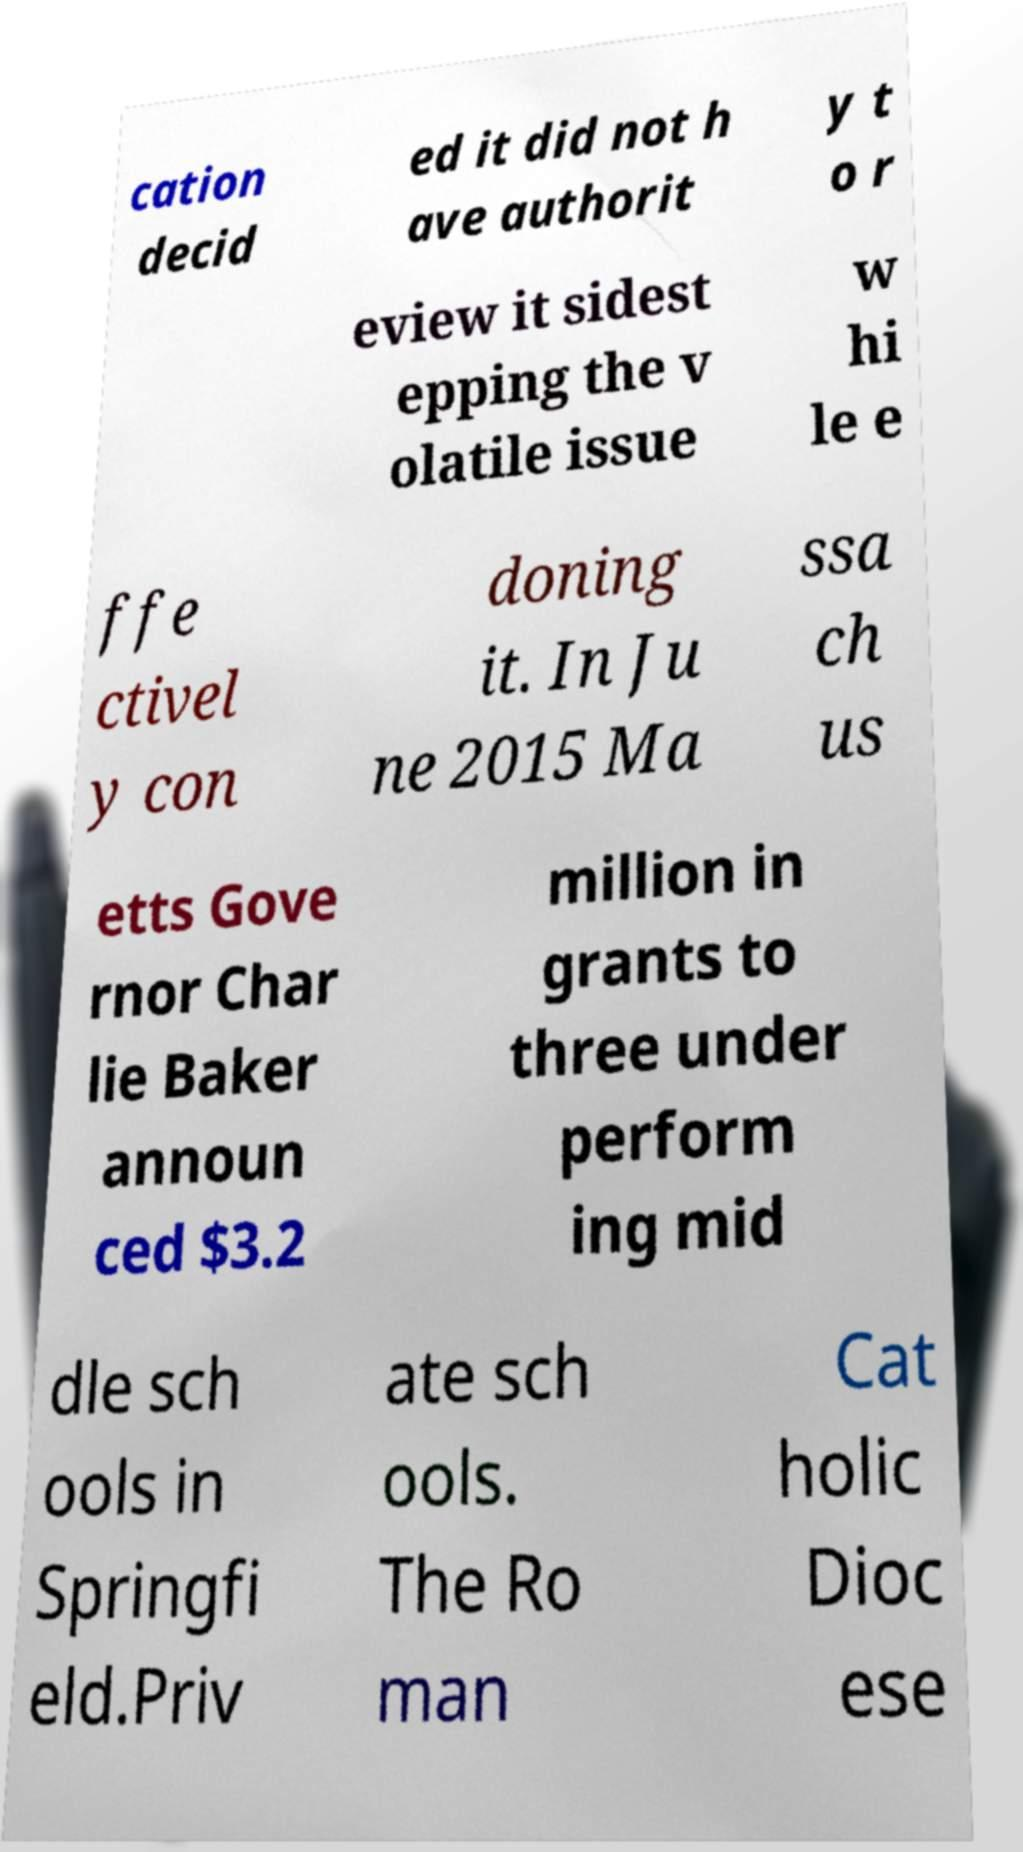For documentation purposes, I need the text within this image transcribed. Could you provide that? cation decid ed it did not h ave authorit y t o r eview it sidest epping the v olatile issue w hi le e ffe ctivel y con doning it. In Ju ne 2015 Ma ssa ch us etts Gove rnor Char lie Baker announ ced $3.2 million in grants to three under perform ing mid dle sch ools in Springfi eld.Priv ate sch ools. The Ro man Cat holic Dioc ese 